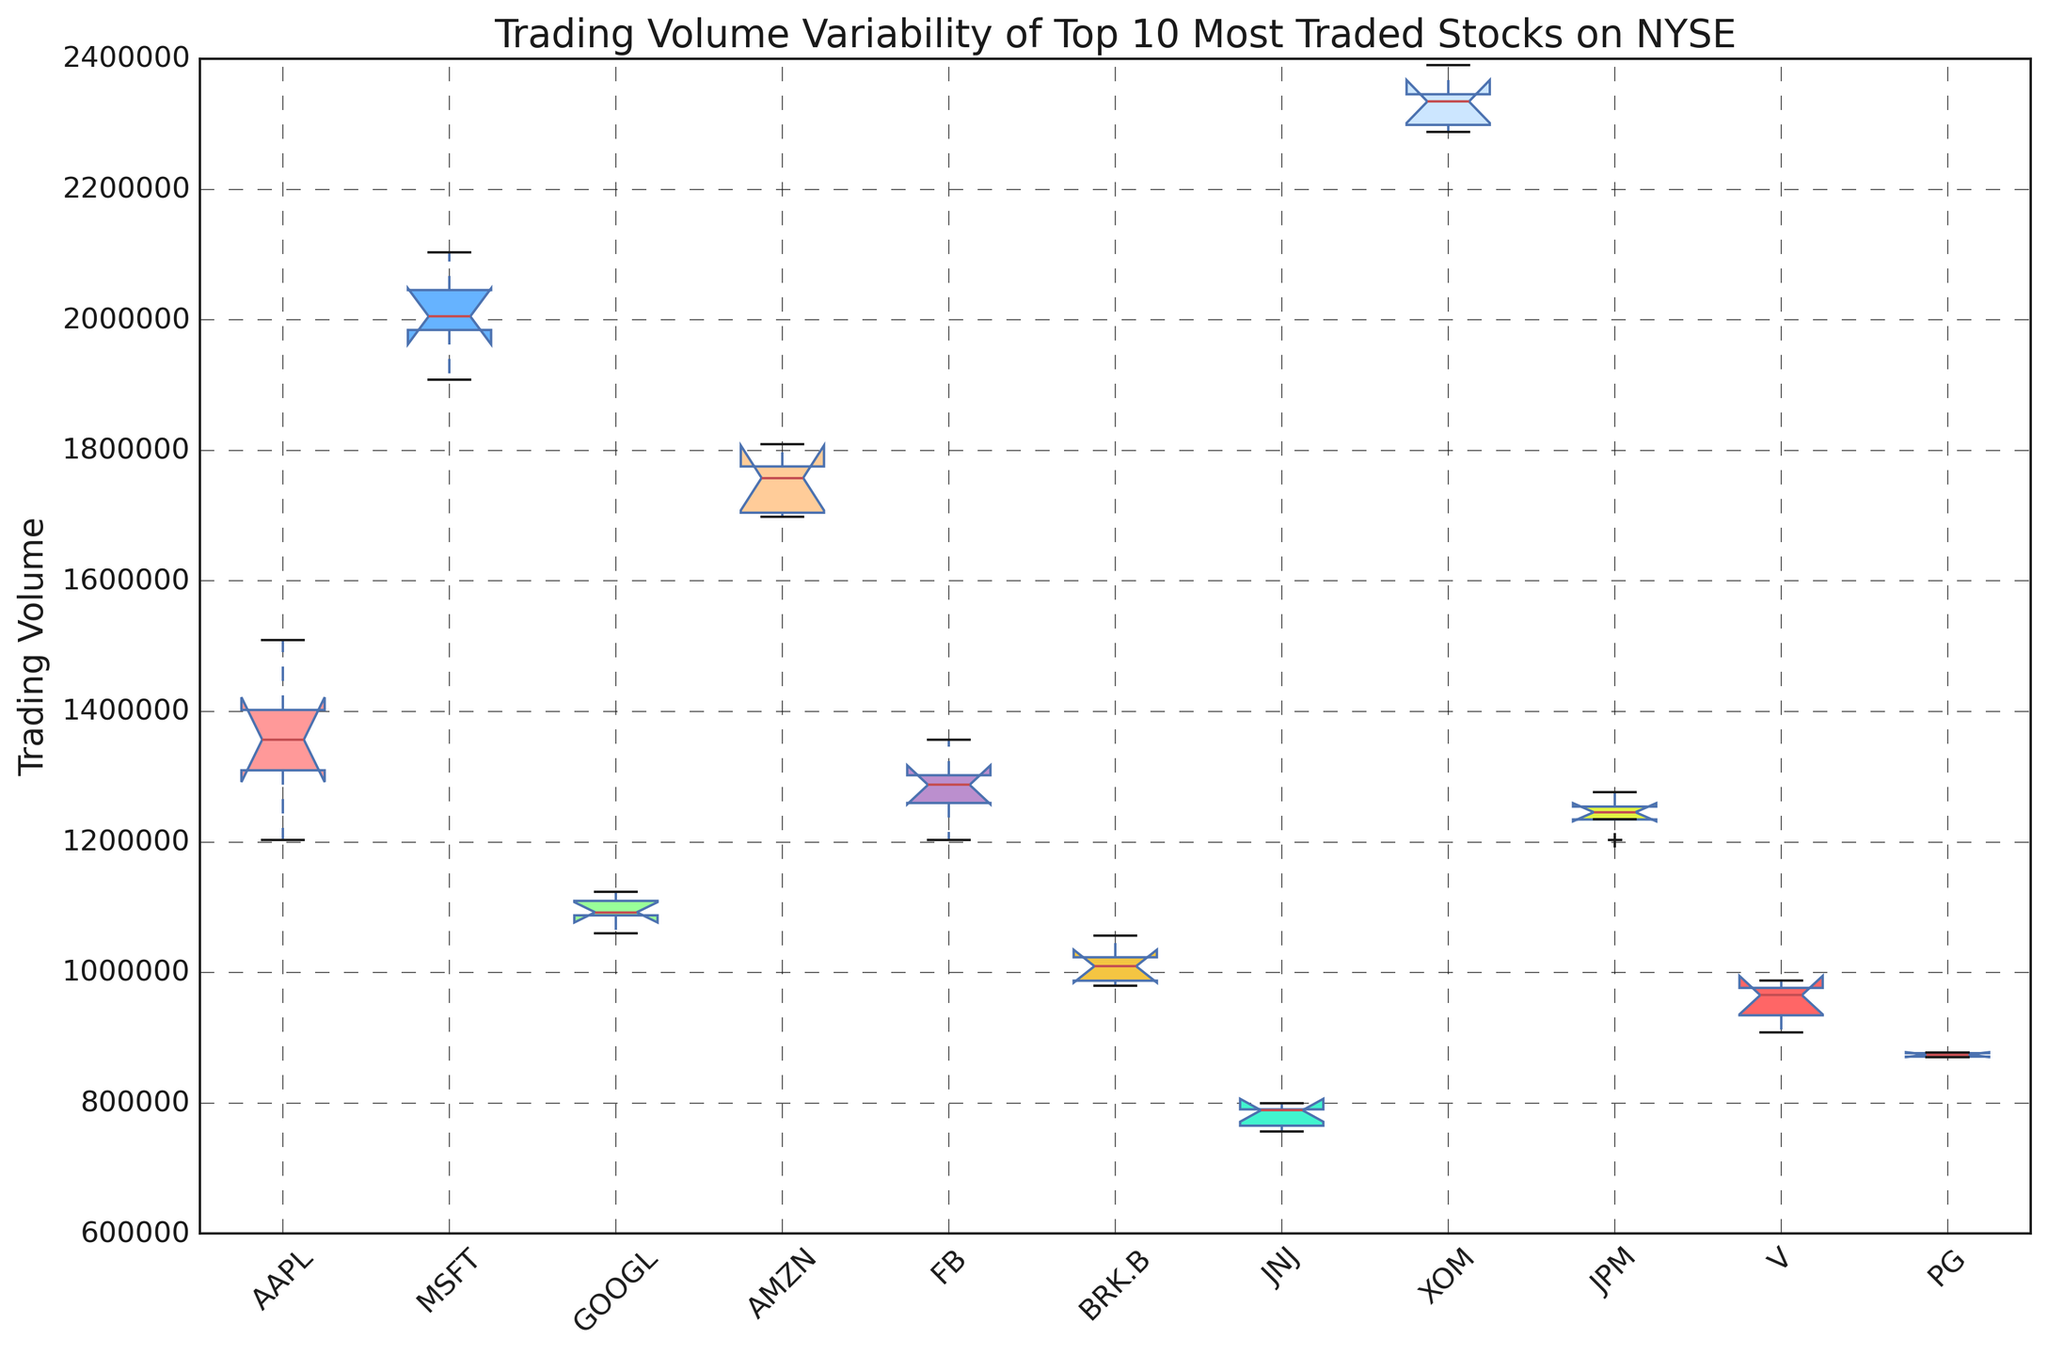Which stock has the highest overall trading volume? Look at the box plot and identify the stock with the highest median value, as indicated by the box's middle line. XOM's trading volume range shows higher values than the other stocks.
Answer: XOM Which stock shows the widest variability in trading volume? The stock with the widest range between its lower whisker to upper whisker, and potentially larger interquartile range (IQR), indicates wider variability. XOM's trading volume range is the broadest in comparison to others.
Answer: XOM Which stock has the smallest median trading volume? Observe the box plots and look for the stock whose box's middle line is the lowest. JNJ's median trading volume is visibly the lowest.
Answer: JNJ Which two stocks have overlapping interquartile ranges? Look for pairs of stocks whose boxes (interquartile ranges) overlap each other vertically. V and PG have interquartile ranges that overlap.
Answer: V and PG Is GOOGL's median trading volume higher or lower than MSFT's median trading volume? Compare the median lines (middle lines of the boxes) of GOOGL and MSFT plots. GOOGL's median line is lower than MSFT's.
Answer: Lower Among AAPL, MSFT, and FB, which has the most consistent trading volume? The consistency in trading volume can be inferred from the shortest interquartile range (IQR) and smaller overall range (whiskers). AAPL has the smallest IQR and range among the three.
Answer: AAPL Are there any stocks with outliers in their trading volume? Look for any dots outside the whiskers, which indicate outliers. There are no dots seen beyond the whiskers for any stock.
Answer: No Which stock's upper whisker extends the highest? Look for the highest point reached by the upper whisker. XOM's upper whisker extends the highest compared to others.
Answer: XOM Rank the stocks from highest to lowest by their median trading volume. Examine the middle lines of each box plot and rank them accordingly: XOM, MSFT, AMZN, AAPL, JPM, FB, GOOGL, BRK.B, PG, V, JNJ.
Answer: XOM > MSFT > AMZN > AAPL > JPM > FB > GOOGL > BRK.B > PG > V > JNJ 